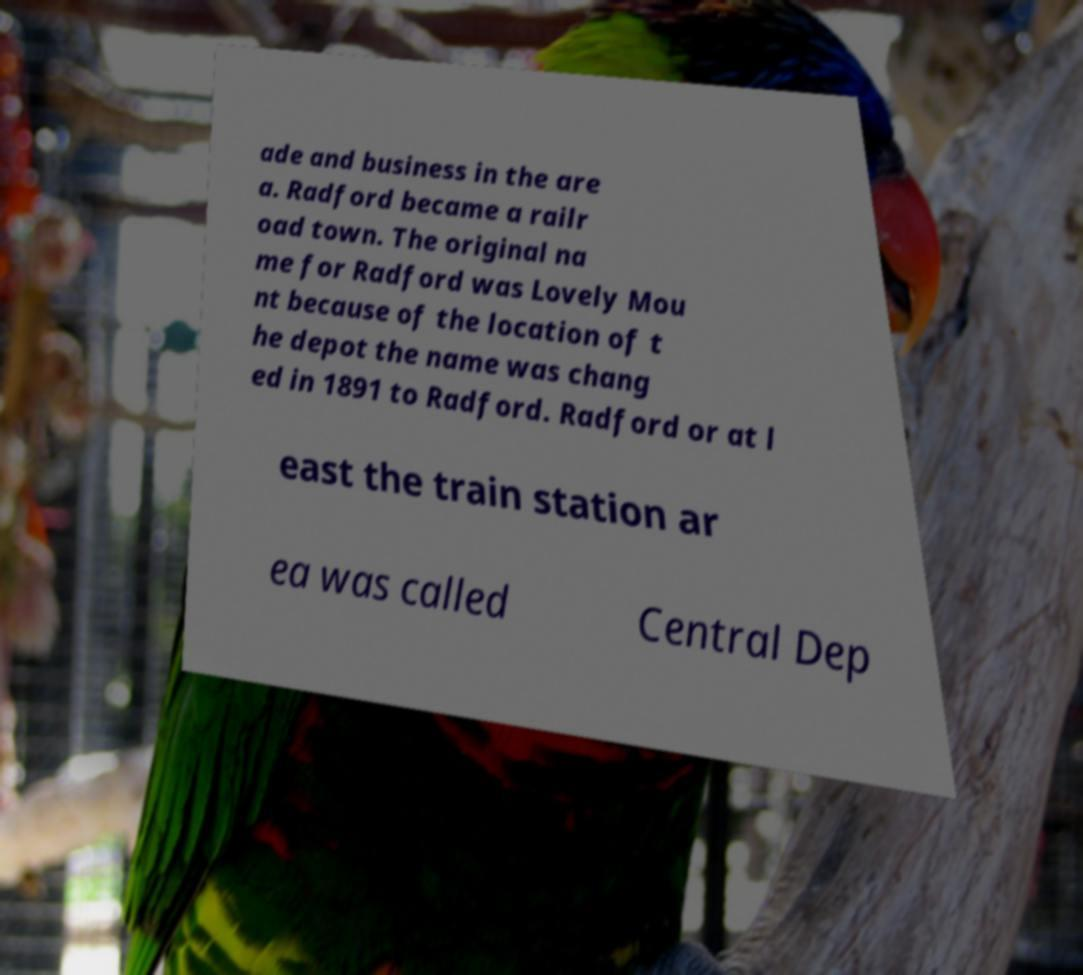Please identify and transcribe the text found in this image. ade and business in the are a. Radford became a railr oad town. The original na me for Radford was Lovely Mou nt because of the location of t he depot the name was chang ed in 1891 to Radford. Radford or at l east the train station ar ea was called Central Dep 